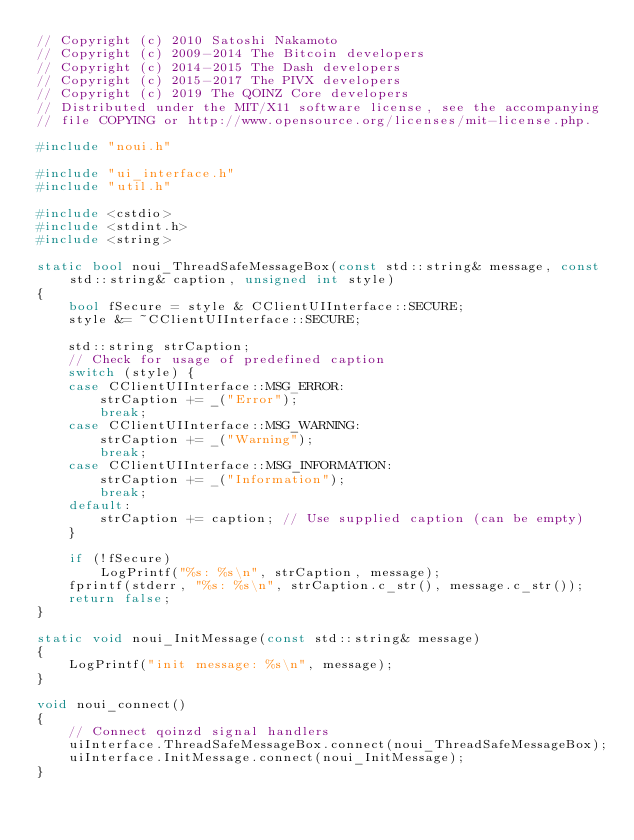Convert code to text. <code><loc_0><loc_0><loc_500><loc_500><_C++_>// Copyright (c) 2010 Satoshi Nakamoto
// Copyright (c) 2009-2014 The Bitcoin developers
// Copyright (c) 2014-2015 The Dash developers
// Copyright (c) 2015-2017 The PIVX developers
// Copyright (c) 2019 The QOINZ Core developers
// Distributed under the MIT/X11 software license, see the accompanying
// file COPYING or http://www.opensource.org/licenses/mit-license.php.

#include "noui.h"

#include "ui_interface.h"
#include "util.h"

#include <cstdio>
#include <stdint.h>
#include <string>

static bool noui_ThreadSafeMessageBox(const std::string& message, const std::string& caption, unsigned int style)
{
    bool fSecure = style & CClientUIInterface::SECURE;
    style &= ~CClientUIInterface::SECURE;

    std::string strCaption;
    // Check for usage of predefined caption
    switch (style) {
    case CClientUIInterface::MSG_ERROR:
        strCaption += _("Error");
        break;
    case CClientUIInterface::MSG_WARNING:
        strCaption += _("Warning");
        break;
    case CClientUIInterface::MSG_INFORMATION:
        strCaption += _("Information");
        break;
    default:
        strCaption += caption; // Use supplied caption (can be empty)
    }

    if (!fSecure)
        LogPrintf("%s: %s\n", strCaption, message);
    fprintf(stderr, "%s: %s\n", strCaption.c_str(), message.c_str());
    return false;
}

static void noui_InitMessage(const std::string& message)
{
    LogPrintf("init message: %s\n", message);
}

void noui_connect()
{
    // Connect qoinzd signal handlers
    uiInterface.ThreadSafeMessageBox.connect(noui_ThreadSafeMessageBox);
    uiInterface.InitMessage.connect(noui_InitMessage);
}
</code> 